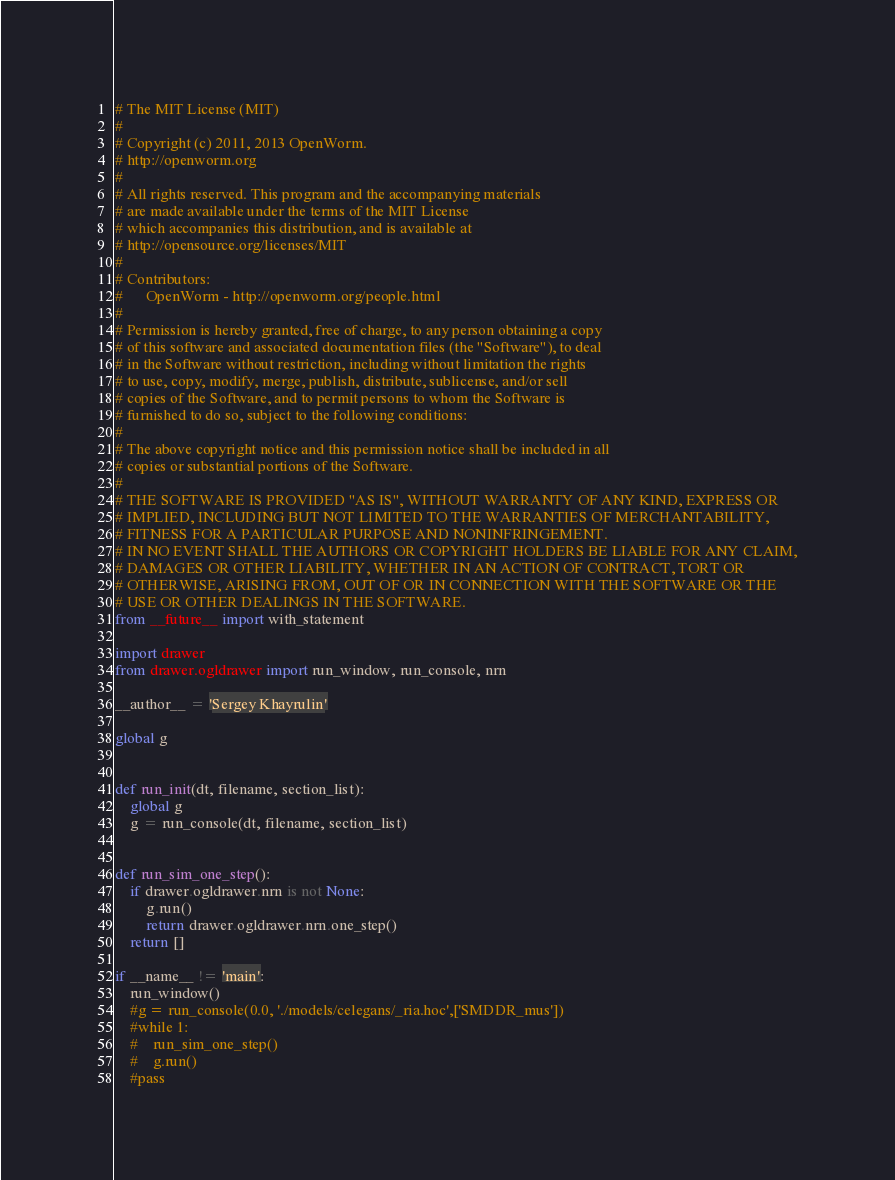Convert code to text. <code><loc_0><loc_0><loc_500><loc_500><_Python_># The MIT License (MIT)
#
# Copyright (c) 2011, 2013 OpenWorm.
# http://openworm.org
#
# All rights reserved. This program and the accompanying materials
# are made available under the terms of the MIT License
# which accompanies this distribution, and is available at
# http://opensource.org/licenses/MIT
#
# Contributors:
#      OpenWorm - http://openworm.org/people.html
#
# Permission is hereby granted, free of charge, to any person obtaining a copy
# of this software and associated documentation files (the "Software"), to deal
# in the Software without restriction, including without limitation the rights
# to use, copy, modify, merge, publish, distribute, sublicense, and/or sell
# copies of the Software, and to permit persons to whom the Software is
# furnished to do so, subject to the following conditions:
#
# The above copyright notice and this permission notice shall be included in all
# copies or substantial portions of the Software.
#
# THE SOFTWARE IS PROVIDED "AS IS", WITHOUT WARRANTY OF ANY KIND, EXPRESS OR
# IMPLIED, INCLUDING BUT NOT LIMITED TO THE WARRANTIES OF MERCHANTABILITY,
# FITNESS FOR A PARTICULAR PURPOSE AND NONINFRINGEMENT.
# IN NO EVENT SHALL THE AUTHORS OR COPYRIGHT HOLDERS BE LIABLE FOR ANY CLAIM,
# DAMAGES OR OTHER LIABILITY, WHETHER IN AN ACTION OF CONTRACT, TORT OR
# OTHERWISE, ARISING FROM, OUT OF OR IN CONNECTION WITH THE SOFTWARE OR THE
# USE OR OTHER DEALINGS IN THE SOFTWARE.
from __future__ import with_statement

import drawer
from drawer.ogldrawer import run_window, run_console, nrn

__author__ = 'Sergey Khayrulin'

global g


def run_init(dt, filename, section_list):
    global g
    g = run_console(dt, filename, section_list)


def run_sim_one_step():
    if drawer.ogldrawer.nrn is not None:
        g.run()
        return drawer.ogldrawer.nrn.one_step()
    return []

if __name__ != 'main':
    run_window()
    #g = run_console(0.0, './models/celegans/_ria.hoc',['SMDDR_mus'])
    #while 1:
    #    run_sim_one_step()
    #    g.run()
    #pass

</code> 